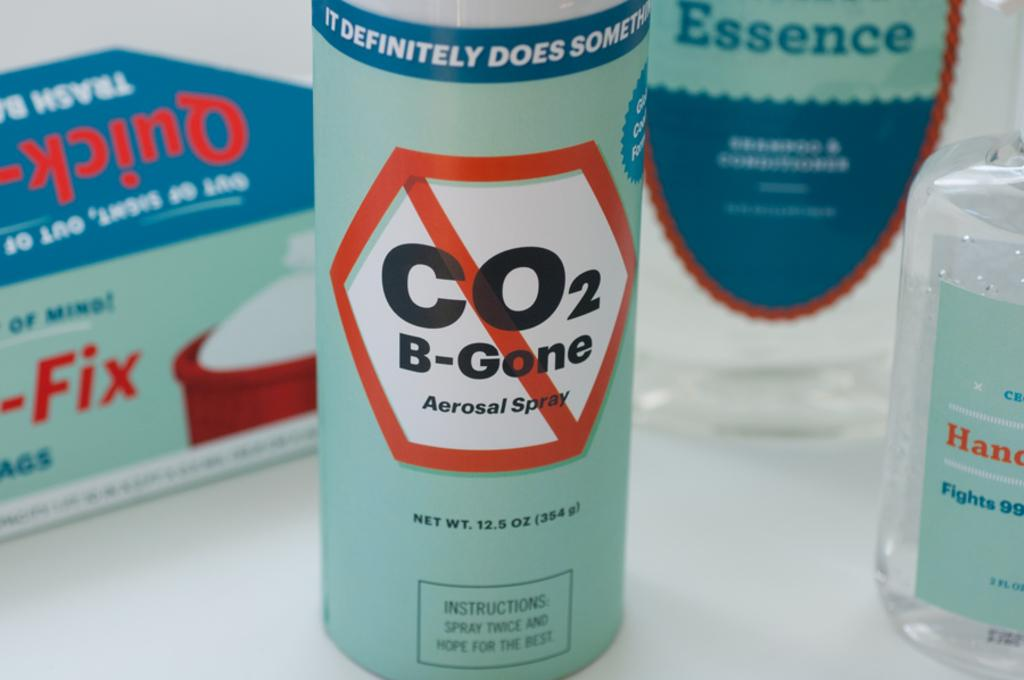<image>
Create a compact narrative representing the image presented. A bottle of spray that is supposed to get rid of carbon dioxide. 